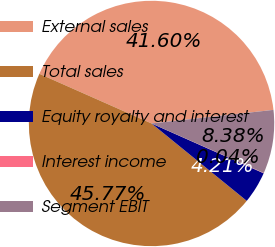<chart> <loc_0><loc_0><loc_500><loc_500><pie_chart><fcel>External sales<fcel>Total sales<fcel>Equity royalty and interest<fcel>Interest income<fcel>Segment EBIT<nl><fcel>41.6%<fcel>45.77%<fcel>4.21%<fcel>0.04%<fcel>8.38%<nl></chart> 